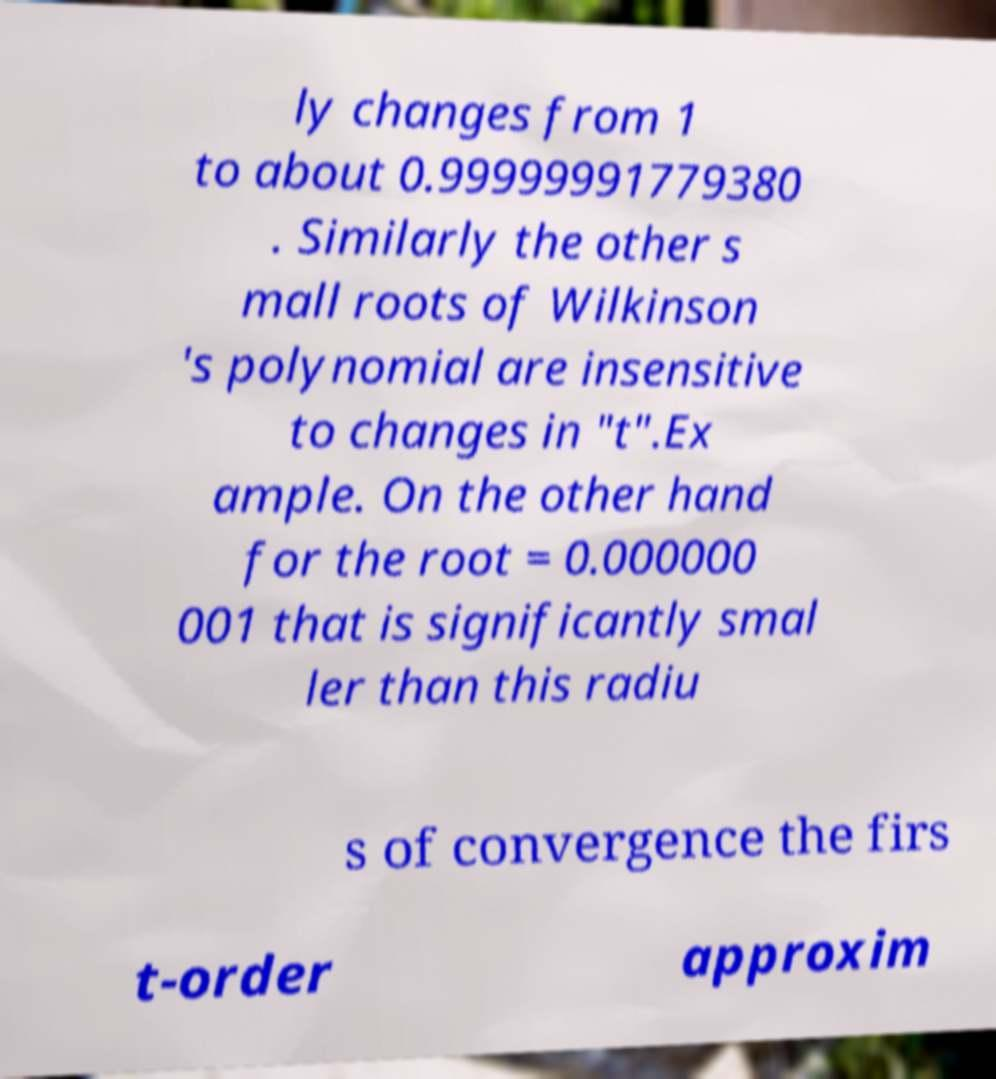Could you assist in decoding the text presented in this image and type it out clearly? ly changes from 1 to about 0.99999991779380 . Similarly the other s mall roots of Wilkinson 's polynomial are insensitive to changes in "t".Ex ample. On the other hand for the root = 0.000000 001 that is significantly smal ler than this radiu s of convergence the firs t-order approxim 